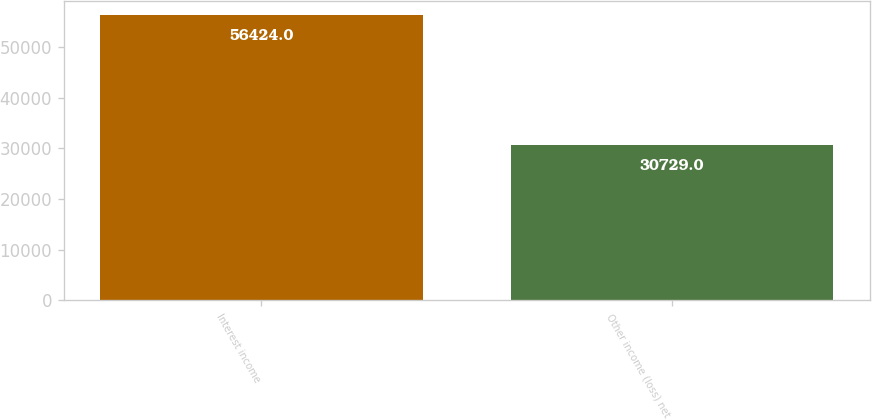<chart> <loc_0><loc_0><loc_500><loc_500><bar_chart><fcel>Interest income<fcel>Other income (loss) net<nl><fcel>56424<fcel>30729<nl></chart> 